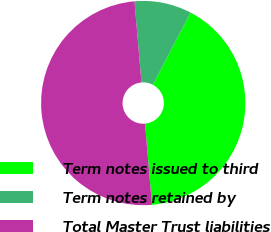<chart> <loc_0><loc_0><loc_500><loc_500><pie_chart><fcel>Term notes issued to third<fcel>Term notes retained by<fcel>Total Master Trust liabilities<nl><fcel>40.95%<fcel>9.05%<fcel>50.0%<nl></chart> 